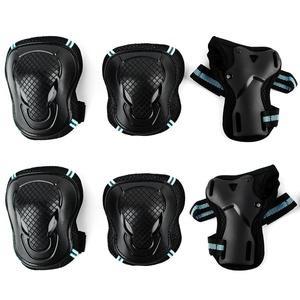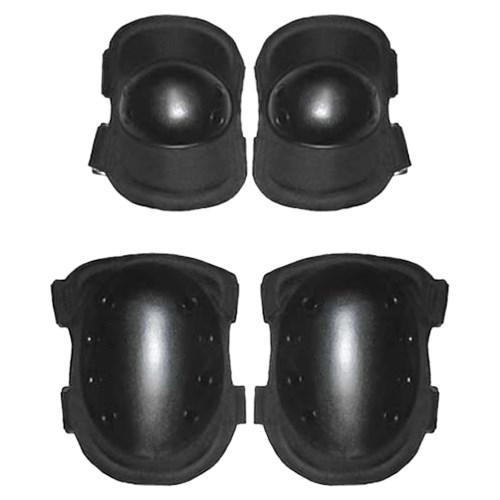The first image is the image on the left, the second image is the image on the right. Analyze the images presented: Is the assertion "There are at least eight pieces of black gear featured." valid? Answer yes or no. Yes. The first image is the image on the left, the second image is the image on the right. Considering the images on both sides, is "At least one image in the set contains exactly four kneepads, with no lettering on them or brand names." valid? Answer yes or no. Yes. 